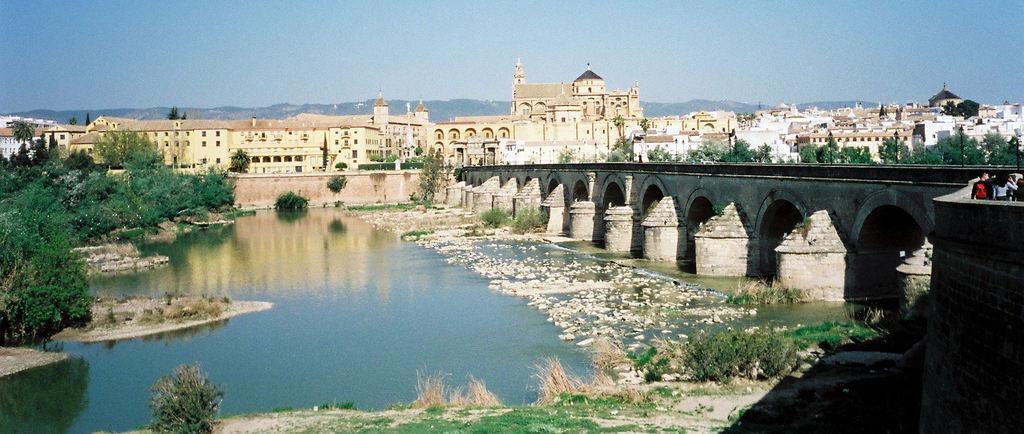Can you describe this image briefly? This is an outside view. At the bottom, I can see the grass and plants on the ground. In the middle of the image there is a sea and I can see the stones in the water. On the right side there is a bridge and few people are walking on it. On the left side there are trees. In the background there are many buildings. At the top of the image I can see the sky. 